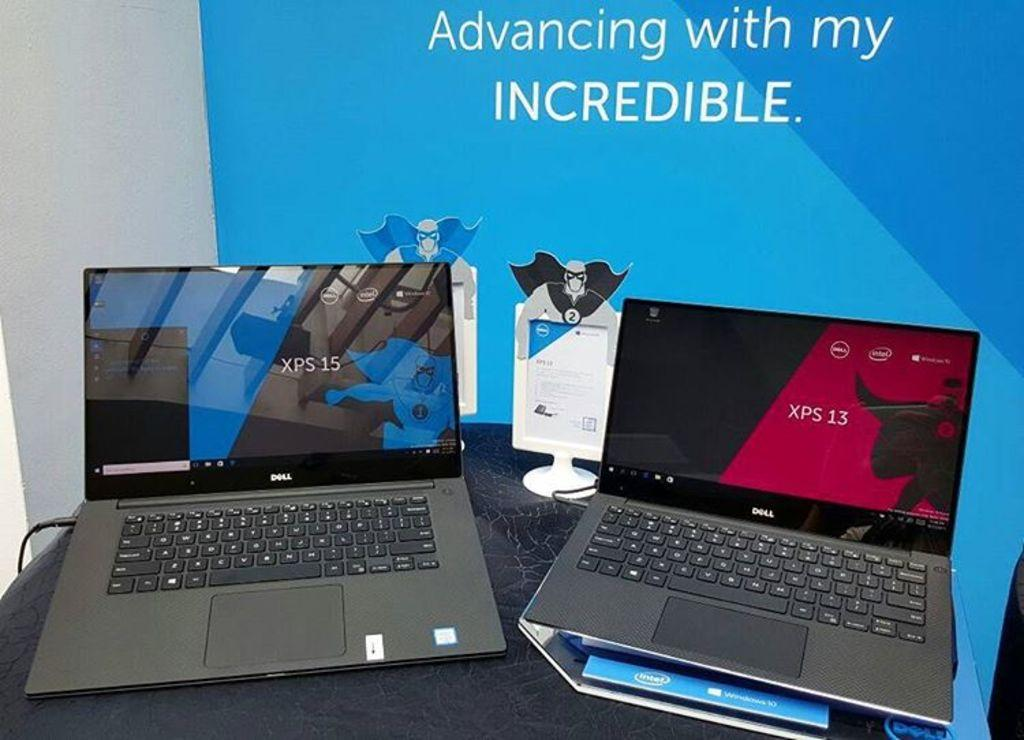<image>
Create a compact narrative representing the image presented. Two black laptop placed in front of a banner that says Advancing with my INCREDIBLE. 